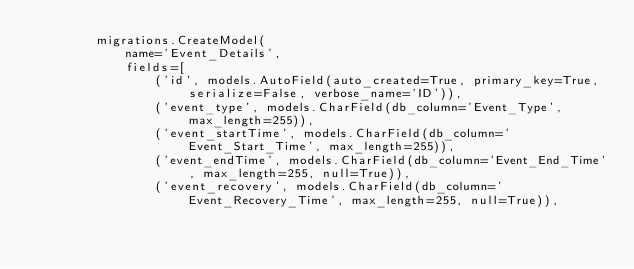<code> <loc_0><loc_0><loc_500><loc_500><_Python_>        migrations.CreateModel(
            name='Event_Details',
            fields=[
                ('id', models.AutoField(auto_created=True, primary_key=True, serialize=False, verbose_name='ID')),
                ('event_type', models.CharField(db_column='Event_Type', max_length=255)),
                ('event_startTime', models.CharField(db_column='Event_Start_Time', max_length=255)),
                ('event_endTime', models.CharField(db_column='Event_End_Time', max_length=255, null=True)),
                ('event_recovery', models.CharField(db_column='Event_Recovery_Time', max_length=255, null=True)),</code> 